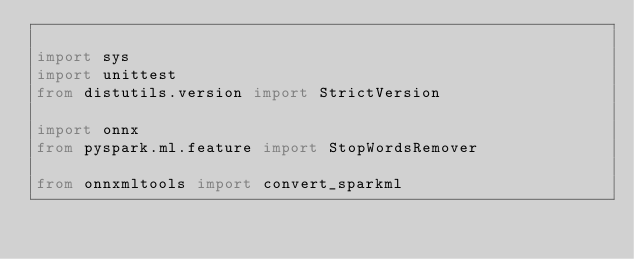Convert code to text. <code><loc_0><loc_0><loc_500><loc_500><_Python_>
import sys
import unittest
from distutils.version import StrictVersion

import onnx
from pyspark.ml.feature import StopWordsRemover

from onnxmltools import convert_sparkml</code> 